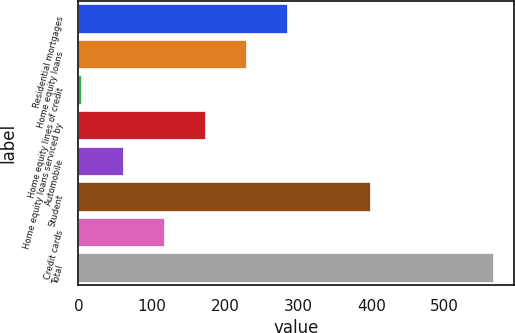Convert chart to OTSL. <chart><loc_0><loc_0><loc_500><loc_500><bar_chart><fcel>Residential mortgages<fcel>Home equity loans<fcel>Home equity lines of credit<fcel>Home equity loans serviced by<fcel>Automobile<fcel>Student<fcel>Credit cards<fcel>Total<nl><fcel>285<fcel>228.8<fcel>4<fcel>172.6<fcel>60.2<fcel>397.4<fcel>116.4<fcel>566<nl></chart> 